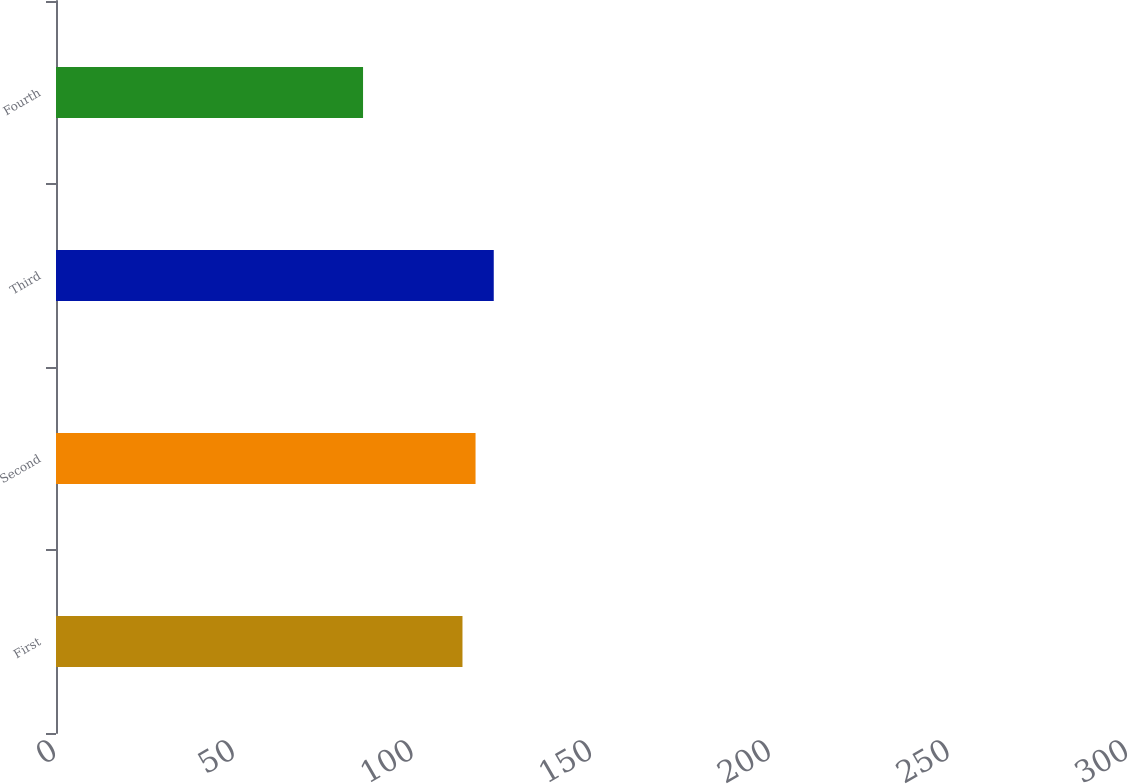Convert chart to OTSL. <chart><loc_0><loc_0><loc_500><loc_500><bar_chart><fcel>First<fcel>Second<fcel>Third<fcel>Fourth<nl><fcel>254.7<fcel>262.89<fcel>274.3<fcel>192.4<nl></chart> 